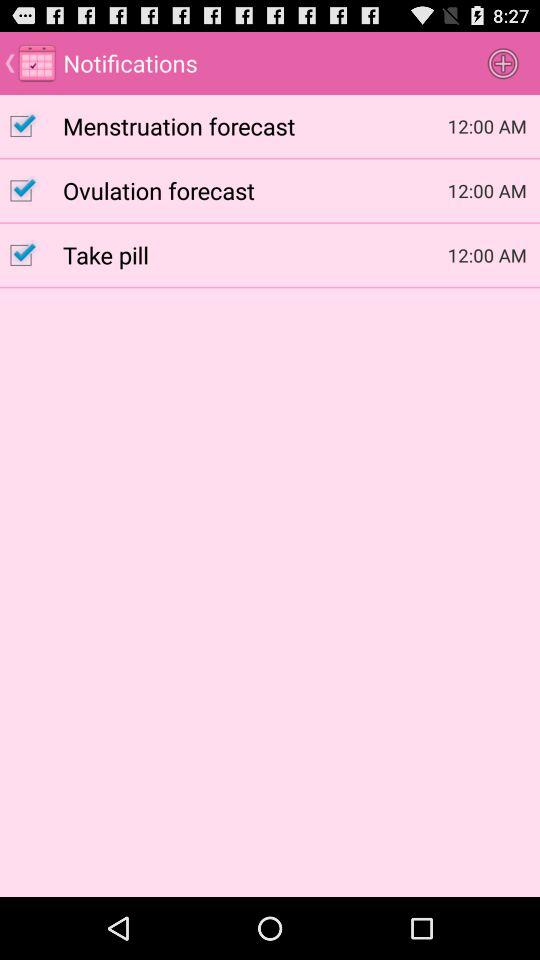What is the status of "Take pill"? The status is "on". 